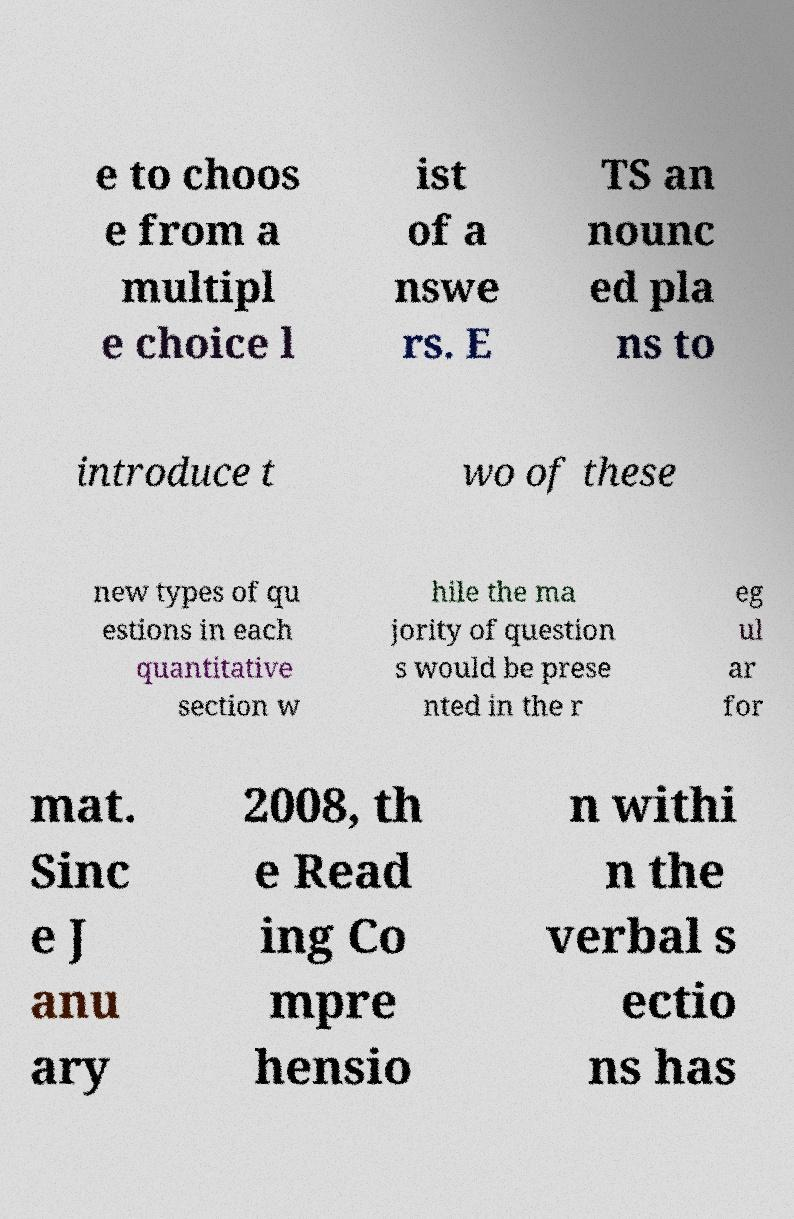Could you assist in decoding the text presented in this image and type it out clearly? e to choos e from a multipl e choice l ist of a nswe rs. E TS an nounc ed pla ns to introduce t wo of these new types of qu estions in each quantitative section w hile the ma jority of question s would be prese nted in the r eg ul ar for mat. Sinc e J anu ary 2008, th e Read ing Co mpre hensio n withi n the verbal s ectio ns has 